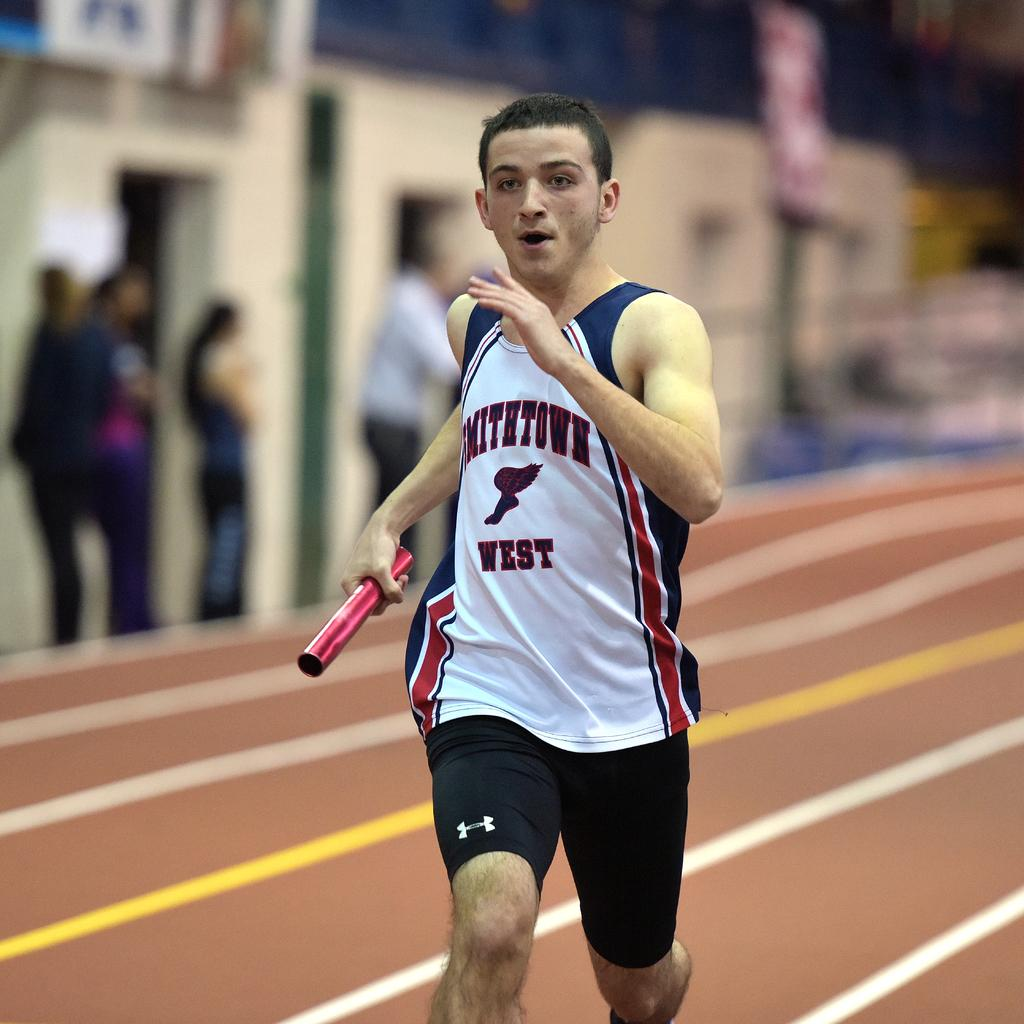<image>
Render a clear and concise summary of the photo. A boy from Smithtown West runs on the track. 